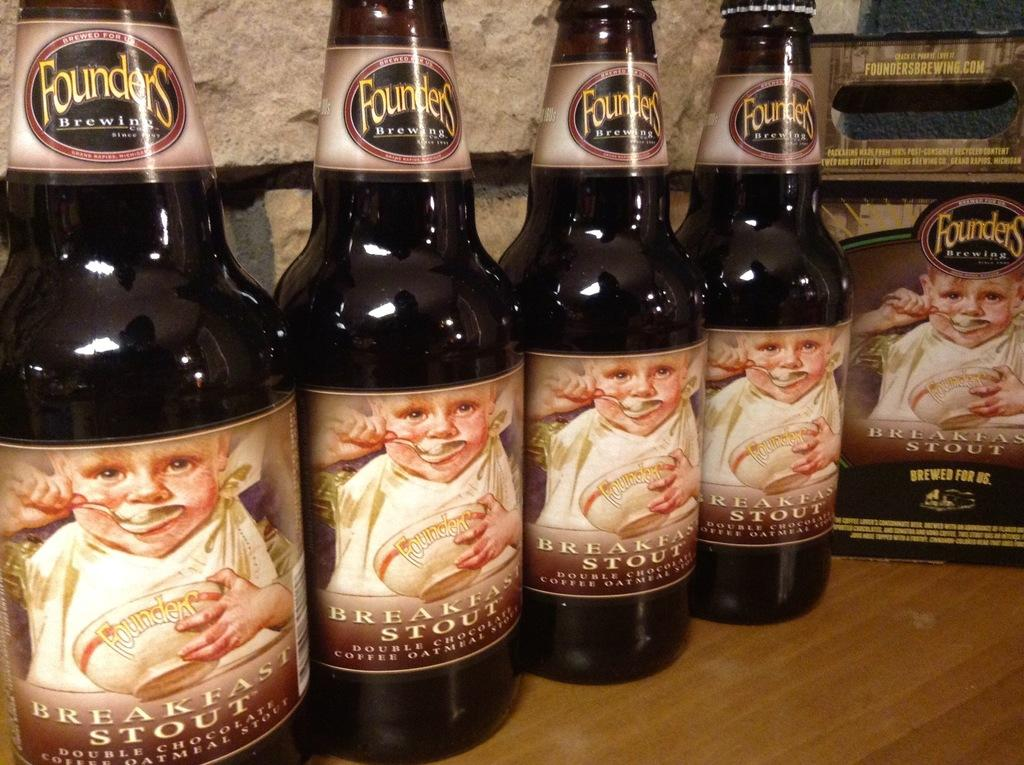<image>
Summarize the visual content of the image. Founders bewing beer that has the label saying Breakfast Stout. 